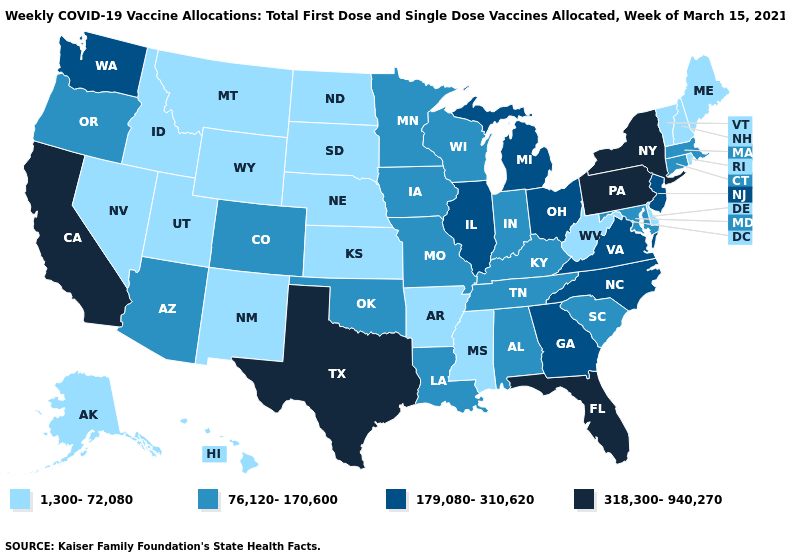How many symbols are there in the legend?
Give a very brief answer. 4. What is the value of Maryland?
Keep it brief. 76,120-170,600. Name the states that have a value in the range 179,080-310,620?
Keep it brief. Georgia, Illinois, Michigan, New Jersey, North Carolina, Ohio, Virginia, Washington. What is the value of New Hampshire?
Write a very short answer. 1,300-72,080. Among the states that border Nebraska , does Missouri have the lowest value?
Short answer required. No. Among the states that border Tennessee , which have the lowest value?
Answer briefly. Arkansas, Mississippi. What is the lowest value in states that border Wisconsin?
Give a very brief answer. 76,120-170,600. What is the highest value in the Northeast ?
Answer briefly. 318,300-940,270. Which states hav the highest value in the MidWest?
Write a very short answer. Illinois, Michigan, Ohio. Name the states that have a value in the range 179,080-310,620?
Be succinct. Georgia, Illinois, Michigan, New Jersey, North Carolina, Ohio, Virginia, Washington. Is the legend a continuous bar?
Keep it brief. No. Name the states that have a value in the range 179,080-310,620?
Keep it brief. Georgia, Illinois, Michigan, New Jersey, North Carolina, Ohio, Virginia, Washington. What is the value of New Hampshire?
Be succinct. 1,300-72,080. What is the value of Washington?
Short answer required. 179,080-310,620. What is the value of Wyoming?
Answer briefly. 1,300-72,080. 